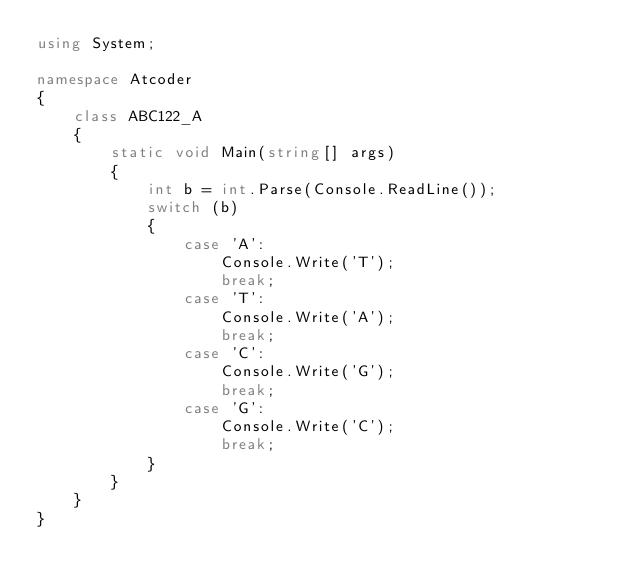<code> <loc_0><loc_0><loc_500><loc_500><_C#_>using System;

namespace Atcoder
{
    class ABC122_A
    {
        static void Main(string[] args)
        {
            int b = int.Parse(Console.ReadLine());
            switch (b)
            {
                case 'A':
                    Console.Write('T');
                    break;
                case 'T':
                    Console.Write('A');
                    break;
                case 'C':
                    Console.Write('G');
                    break;
                case 'G':
                    Console.Write('C');
                    break;
            }
        }
    }
}
</code> 